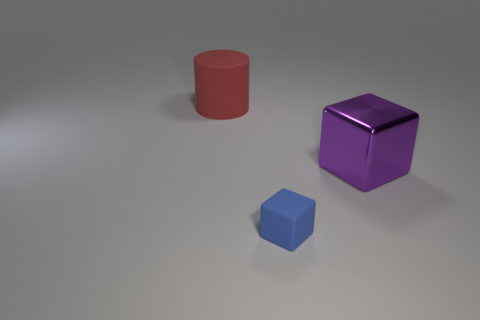What could be the context in which these objects are present? These objects could be part of a visual representation intended to compare and contrast geometric forms, colors, or perhaps to illustrate the concept of scaling or perspective in a 3D environment. They could also be used in educational settings or be elements of a simple rendering test for a graphics software. 